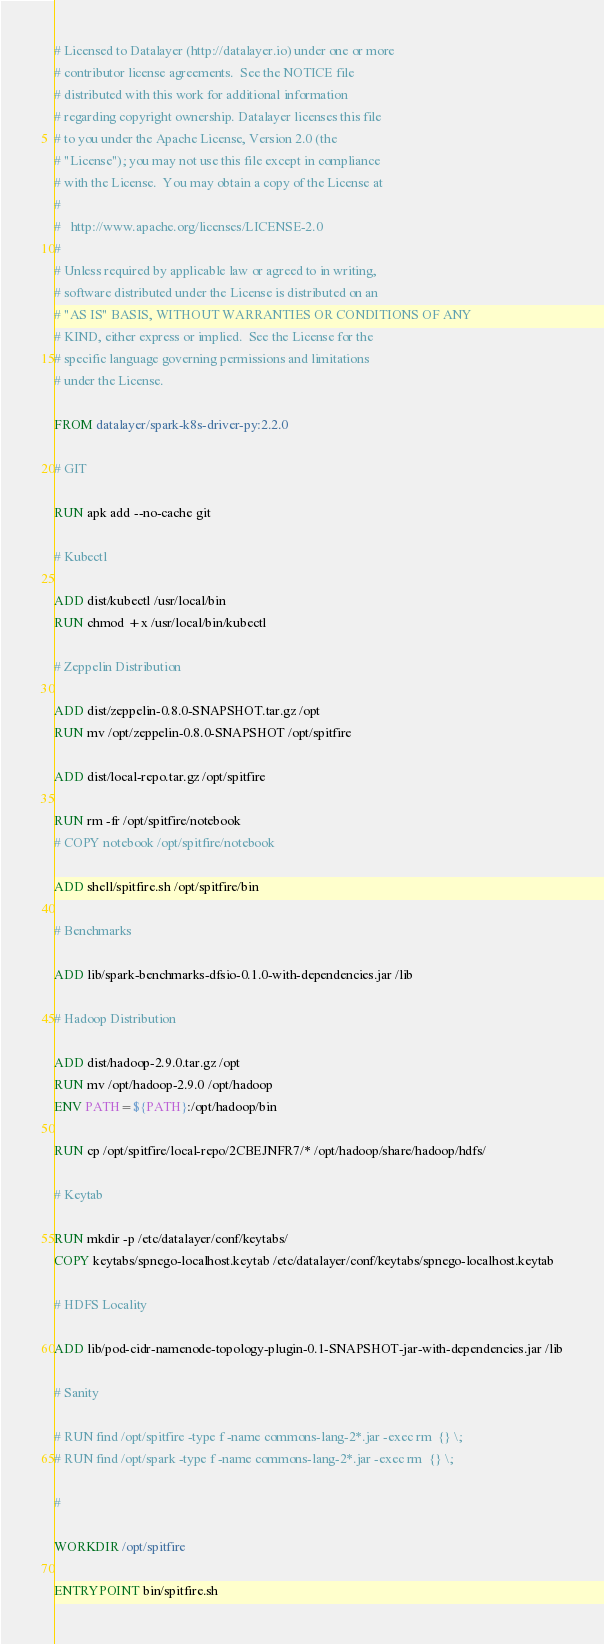<code> <loc_0><loc_0><loc_500><loc_500><_Dockerfile_># Licensed to Datalayer (http://datalayer.io) under one or more
# contributor license agreements.  See the NOTICE file
# distributed with this work for additional information
# regarding copyright ownership. Datalayer licenses this file
# to you under the Apache License, Version 2.0 (the 
# "License"); you may not use this file except in compliance
# with the License.  You may obtain a copy of the License at
#
#   http://www.apache.org/licenses/LICENSE-2.0
#
# Unless required by applicable law or agreed to in writing,
# software distributed under the License is distributed on an
# "AS IS" BASIS, WITHOUT WARRANTIES OR CONDITIONS OF ANY
# KIND, either express or implied.  See the License for the
# specific language governing permissions and limitations
# under the License.

FROM datalayer/spark-k8s-driver-py:2.2.0

# GIT

RUN apk add --no-cache git

# Kubectl

ADD dist/kubectl /usr/local/bin
RUN chmod +x /usr/local/bin/kubectl

# Zeppelin Distribution

ADD dist/zeppelin-0.8.0-SNAPSHOT.tar.gz /opt
RUN mv /opt/zeppelin-0.8.0-SNAPSHOT /opt/spitfire

ADD dist/local-repo.tar.gz /opt/spitfire

RUN rm -fr /opt/spitfire/notebook
# COPY notebook /opt/spitfire/notebook

ADD shell/spitfire.sh /opt/spitfire/bin

# Benchmarks

ADD lib/spark-benchmarks-dfsio-0.1.0-with-dependencies.jar /lib

# Hadoop Distribution

ADD dist/hadoop-2.9.0.tar.gz /opt
RUN mv /opt/hadoop-2.9.0 /opt/hadoop
ENV PATH=${PATH}:/opt/hadoop/bin

RUN cp /opt/spitfire/local-repo/2CBEJNFR7/* /opt/hadoop/share/hadoop/hdfs/

# Keytab

RUN mkdir -p /etc/datalayer/conf/keytabs/
COPY keytabs/spnego-localhost.keytab /etc/datalayer/conf/keytabs/spnego-localhost.keytab

# HDFS Locality

ADD lib/pod-cidr-namenode-topology-plugin-0.1-SNAPSHOT-jar-with-dependencies.jar /lib

# Sanity

# RUN find /opt/spitfire -type f -name commons-lang-2*.jar -exec rm  {} \;
# RUN find /opt/spark -type f -name commons-lang-2*.jar -exec rm  {} \;

# 

WORKDIR /opt/spitfire

ENTRYPOINT bin/spitfire.sh
</code> 